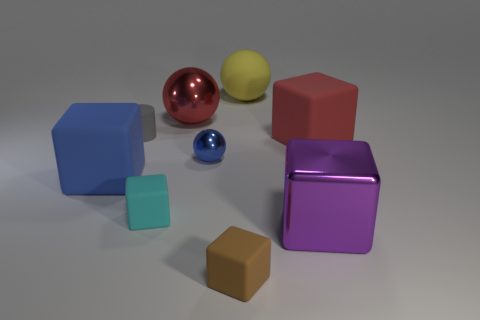How many big gray spheres are there?
Your answer should be compact. 0. There is a small object that is the same shape as the large yellow thing; what material is it?
Offer a very short reply. Metal. Is the material of the red object behind the big red cube the same as the red block?
Offer a very short reply. No. Are there more small gray matte objects that are to the right of the large metal cube than tiny blue shiny objects that are to the left of the blue metal ball?
Offer a very short reply. No. The red sphere has what size?
Ensure brevity in your answer.  Large. What is the shape of the big yellow thing that is the same material as the cyan block?
Your answer should be very brief. Sphere. Do the purple metallic object in front of the large yellow sphere and the small brown matte thing have the same shape?
Keep it short and to the point. Yes. What number of things are either tiny red metallic cylinders or tiny cubes?
Your answer should be very brief. 2. What material is the big object that is both on the left side of the brown thing and on the right side of the blue rubber cube?
Make the answer very short. Metal. Do the yellow thing and the blue rubber block have the same size?
Your answer should be compact. Yes. 